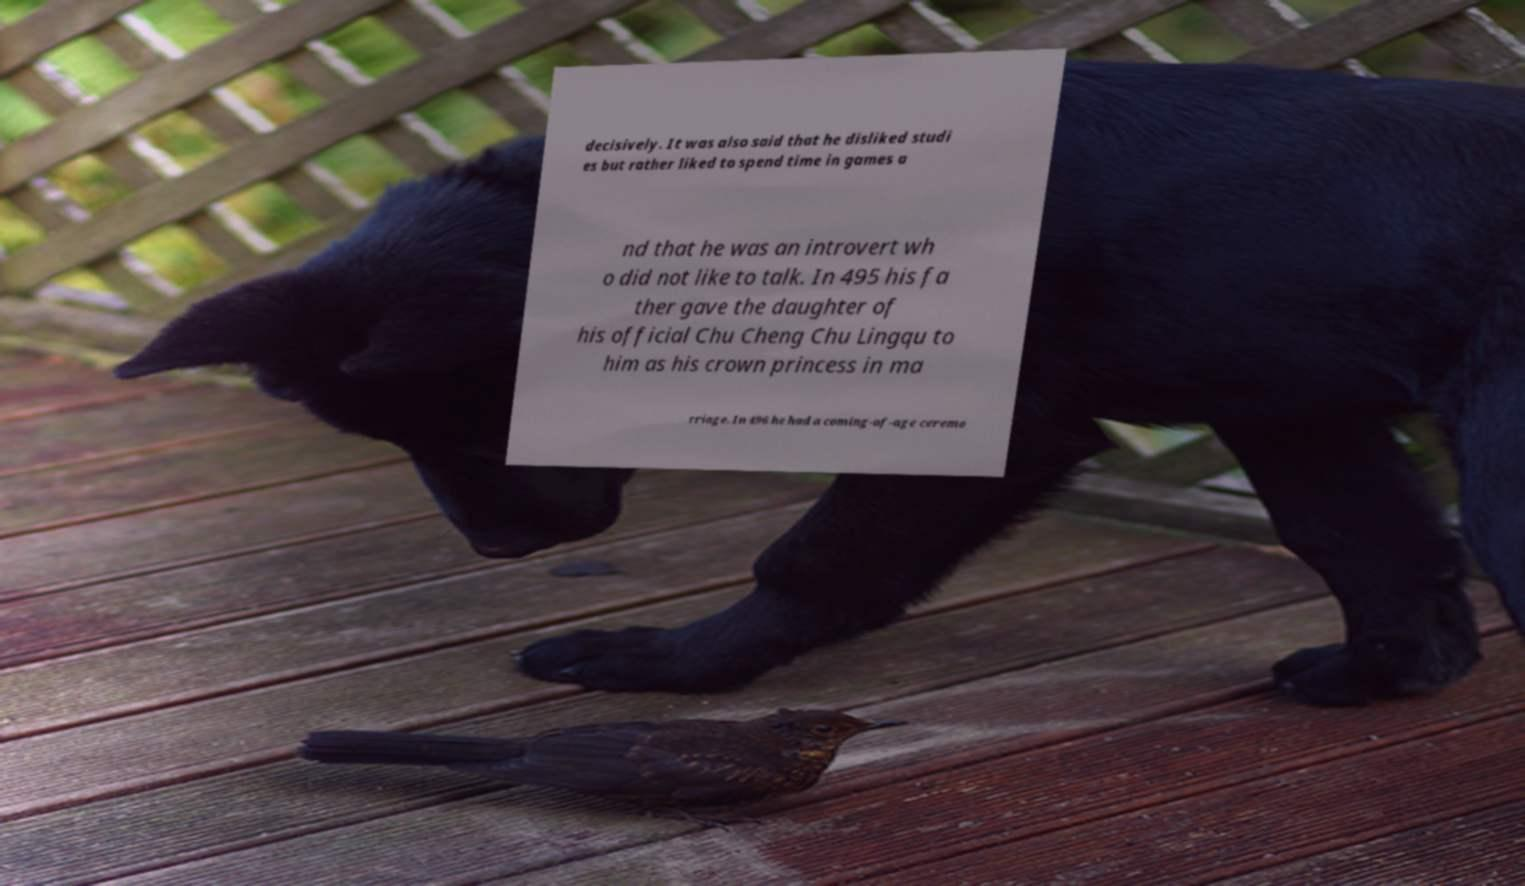Can you read and provide the text displayed in the image?This photo seems to have some interesting text. Can you extract and type it out for me? decisively. It was also said that he disliked studi es but rather liked to spend time in games a nd that he was an introvert wh o did not like to talk. In 495 his fa ther gave the daughter of his official Chu Cheng Chu Lingqu to him as his crown princess in ma rriage. In 496 he had a coming-of-age ceremo 